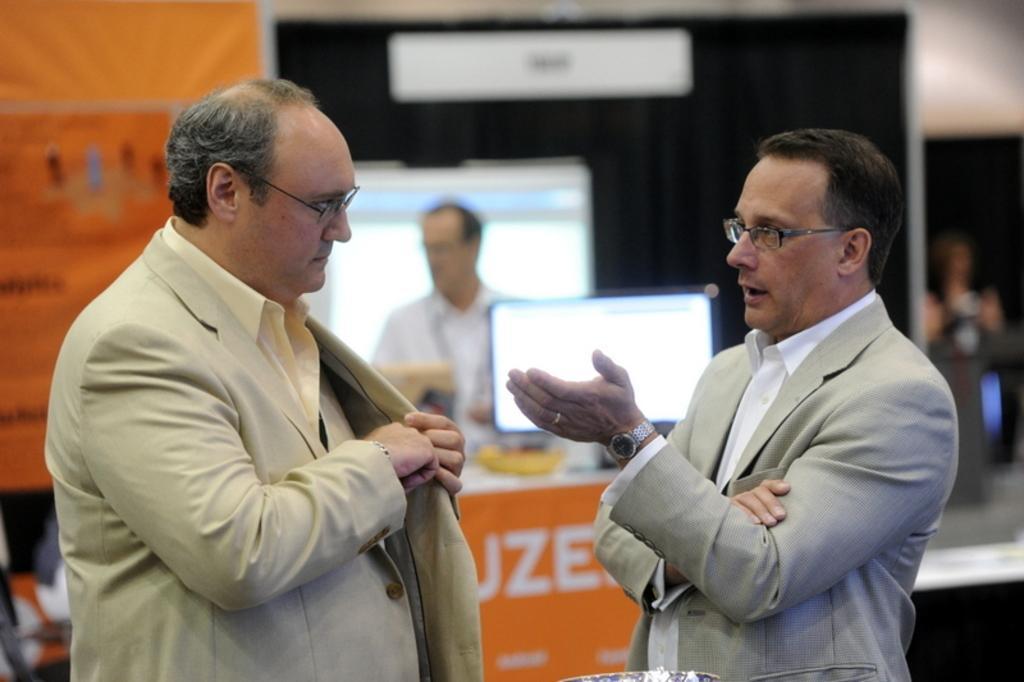In one or two sentences, can you explain what this image depicts? In the image there are two men in the foreground, the second person is talking something and the background of the men is blur. 